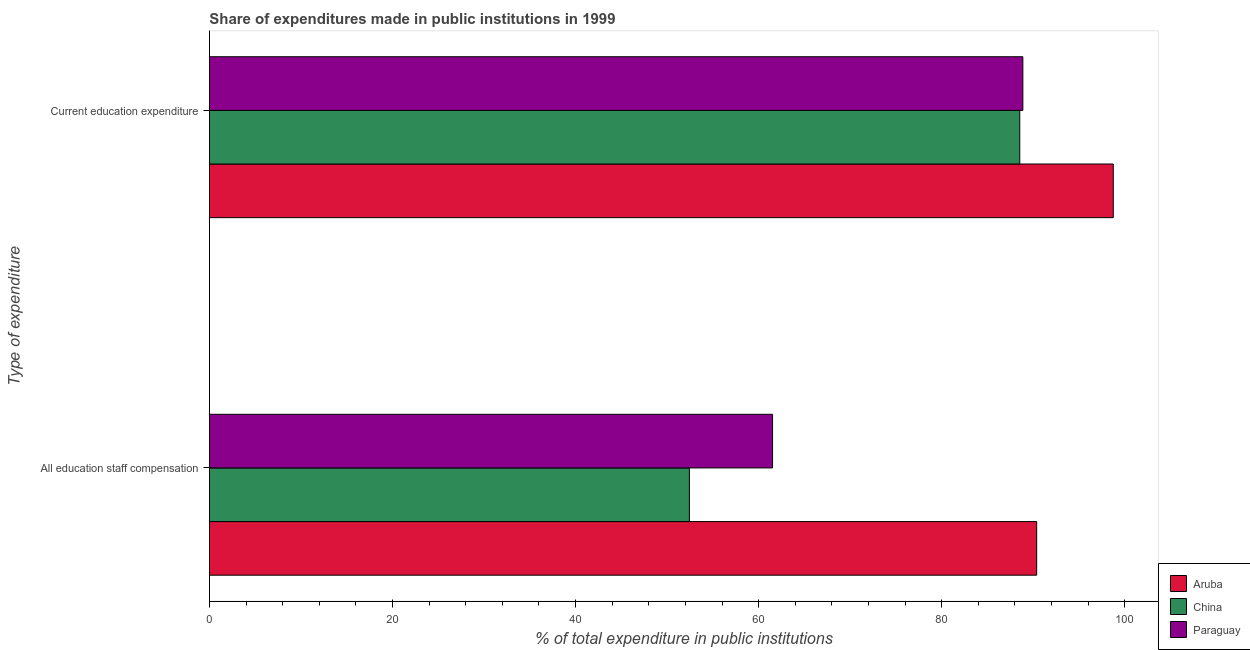Are the number of bars on each tick of the Y-axis equal?
Offer a terse response. Yes. How many bars are there on the 1st tick from the bottom?
Make the answer very short. 3. What is the label of the 1st group of bars from the top?
Offer a very short reply. Current education expenditure. What is the expenditure in education in Aruba?
Make the answer very short. 98.74. Across all countries, what is the maximum expenditure in staff compensation?
Offer a terse response. 90.37. Across all countries, what is the minimum expenditure in education?
Your answer should be compact. 88.52. In which country was the expenditure in staff compensation maximum?
Your answer should be very brief. Aruba. What is the total expenditure in education in the graph?
Provide a short and direct response. 276.12. What is the difference between the expenditure in education in Paraguay and that in Aruba?
Your answer should be compact. -9.88. What is the difference between the expenditure in education in Paraguay and the expenditure in staff compensation in China?
Make the answer very short. 36.43. What is the average expenditure in education per country?
Your response must be concise. 92.04. What is the difference between the expenditure in staff compensation and expenditure in education in Aruba?
Your answer should be compact. -8.37. In how many countries, is the expenditure in education greater than 44 %?
Your answer should be compact. 3. What is the ratio of the expenditure in education in Aruba to that in China?
Offer a terse response. 1.12. In how many countries, is the expenditure in staff compensation greater than the average expenditure in staff compensation taken over all countries?
Your answer should be compact. 1. What does the 3rd bar from the top in Current education expenditure represents?
Your response must be concise. Aruba. What does the 2nd bar from the bottom in Current education expenditure represents?
Your answer should be very brief. China. How many bars are there?
Your answer should be very brief. 6. How many countries are there in the graph?
Your answer should be compact. 3. Are the values on the major ticks of X-axis written in scientific E-notation?
Give a very brief answer. No. Does the graph contain any zero values?
Your response must be concise. No. How many legend labels are there?
Offer a terse response. 3. How are the legend labels stacked?
Keep it short and to the point. Vertical. What is the title of the graph?
Your answer should be very brief. Share of expenditures made in public institutions in 1999. Does "Bangladesh" appear as one of the legend labels in the graph?
Your response must be concise. No. What is the label or title of the X-axis?
Your answer should be compact. % of total expenditure in public institutions. What is the label or title of the Y-axis?
Your answer should be compact. Type of expenditure. What is the % of total expenditure in public institutions of Aruba in All education staff compensation?
Keep it short and to the point. 90.37. What is the % of total expenditure in public institutions in China in All education staff compensation?
Provide a succinct answer. 52.43. What is the % of total expenditure in public institutions of Paraguay in All education staff compensation?
Your response must be concise. 61.52. What is the % of total expenditure in public institutions of Aruba in Current education expenditure?
Give a very brief answer. 98.74. What is the % of total expenditure in public institutions in China in Current education expenditure?
Your response must be concise. 88.52. What is the % of total expenditure in public institutions of Paraguay in Current education expenditure?
Your answer should be very brief. 88.86. Across all Type of expenditure, what is the maximum % of total expenditure in public institutions of Aruba?
Offer a very short reply. 98.74. Across all Type of expenditure, what is the maximum % of total expenditure in public institutions of China?
Your answer should be compact. 88.52. Across all Type of expenditure, what is the maximum % of total expenditure in public institutions of Paraguay?
Give a very brief answer. 88.86. Across all Type of expenditure, what is the minimum % of total expenditure in public institutions in Aruba?
Provide a short and direct response. 90.37. Across all Type of expenditure, what is the minimum % of total expenditure in public institutions in China?
Give a very brief answer. 52.43. Across all Type of expenditure, what is the minimum % of total expenditure in public institutions of Paraguay?
Offer a very short reply. 61.52. What is the total % of total expenditure in public institutions of Aruba in the graph?
Ensure brevity in your answer.  189.11. What is the total % of total expenditure in public institutions in China in the graph?
Provide a succinct answer. 140.96. What is the total % of total expenditure in public institutions of Paraguay in the graph?
Your response must be concise. 150.38. What is the difference between the % of total expenditure in public institutions in Aruba in All education staff compensation and that in Current education expenditure?
Your answer should be very brief. -8.37. What is the difference between the % of total expenditure in public institutions of China in All education staff compensation and that in Current education expenditure?
Give a very brief answer. -36.09. What is the difference between the % of total expenditure in public institutions of Paraguay in All education staff compensation and that in Current education expenditure?
Provide a succinct answer. -27.34. What is the difference between the % of total expenditure in public institutions in Aruba in All education staff compensation and the % of total expenditure in public institutions in China in Current education expenditure?
Make the answer very short. 1.85. What is the difference between the % of total expenditure in public institutions of Aruba in All education staff compensation and the % of total expenditure in public institutions of Paraguay in Current education expenditure?
Offer a terse response. 1.51. What is the difference between the % of total expenditure in public institutions in China in All education staff compensation and the % of total expenditure in public institutions in Paraguay in Current education expenditure?
Offer a very short reply. -36.43. What is the average % of total expenditure in public institutions of Aruba per Type of expenditure?
Offer a terse response. 94.55. What is the average % of total expenditure in public institutions of China per Type of expenditure?
Make the answer very short. 70.48. What is the average % of total expenditure in public institutions in Paraguay per Type of expenditure?
Keep it short and to the point. 75.19. What is the difference between the % of total expenditure in public institutions of Aruba and % of total expenditure in public institutions of China in All education staff compensation?
Provide a short and direct response. 37.94. What is the difference between the % of total expenditure in public institutions of Aruba and % of total expenditure in public institutions of Paraguay in All education staff compensation?
Offer a terse response. 28.85. What is the difference between the % of total expenditure in public institutions of China and % of total expenditure in public institutions of Paraguay in All education staff compensation?
Your response must be concise. -9.09. What is the difference between the % of total expenditure in public institutions of Aruba and % of total expenditure in public institutions of China in Current education expenditure?
Your answer should be compact. 10.21. What is the difference between the % of total expenditure in public institutions of Aruba and % of total expenditure in public institutions of Paraguay in Current education expenditure?
Offer a very short reply. 9.88. What is the difference between the % of total expenditure in public institutions of China and % of total expenditure in public institutions of Paraguay in Current education expenditure?
Provide a succinct answer. -0.34. What is the ratio of the % of total expenditure in public institutions in Aruba in All education staff compensation to that in Current education expenditure?
Ensure brevity in your answer.  0.92. What is the ratio of the % of total expenditure in public institutions in China in All education staff compensation to that in Current education expenditure?
Your answer should be very brief. 0.59. What is the ratio of the % of total expenditure in public institutions of Paraguay in All education staff compensation to that in Current education expenditure?
Offer a very short reply. 0.69. What is the difference between the highest and the second highest % of total expenditure in public institutions of Aruba?
Offer a very short reply. 8.37. What is the difference between the highest and the second highest % of total expenditure in public institutions in China?
Provide a succinct answer. 36.09. What is the difference between the highest and the second highest % of total expenditure in public institutions in Paraguay?
Your answer should be very brief. 27.34. What is the difference between the highest and the lowest % of total expenditure in public institutions in Aruba?
Your answer should be compact. 8.37. What is the difference between the highest and the lowest % of total expenditure in public institutions in China?
Offer a terse response. 36.09. What is the difference between the highest and the lowest % of total expenditure in public institutions in Paraguay?
Provide a succinct answer. 27.34. 